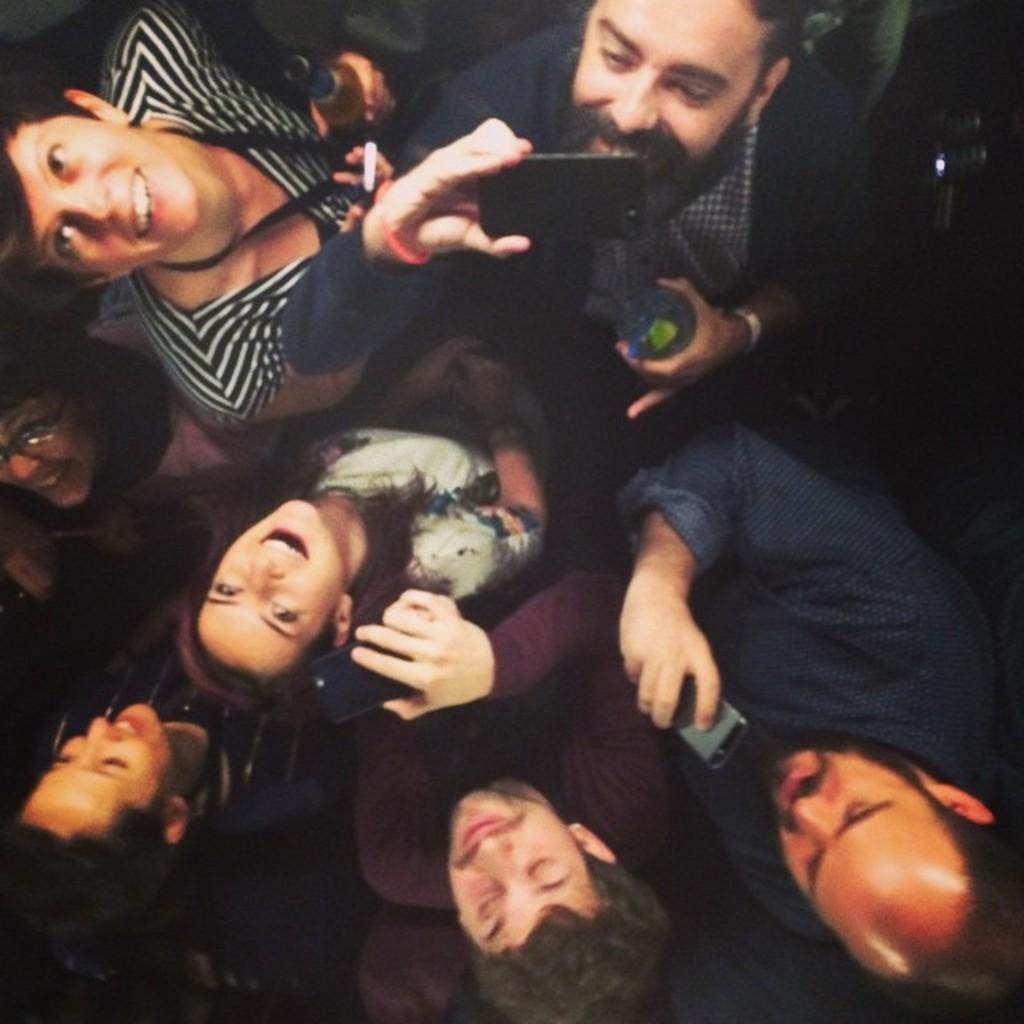What is the main subject of the image? The main subject of the image is a group of people. Can you describe what the people in the group are doing? Some people in the group are holding objects in their hands. Who is wearing the crown in the image? There is no crown present in the image. What process is being followed by the group in the image? The image does not depict a specific process or activity being followed by the group. 